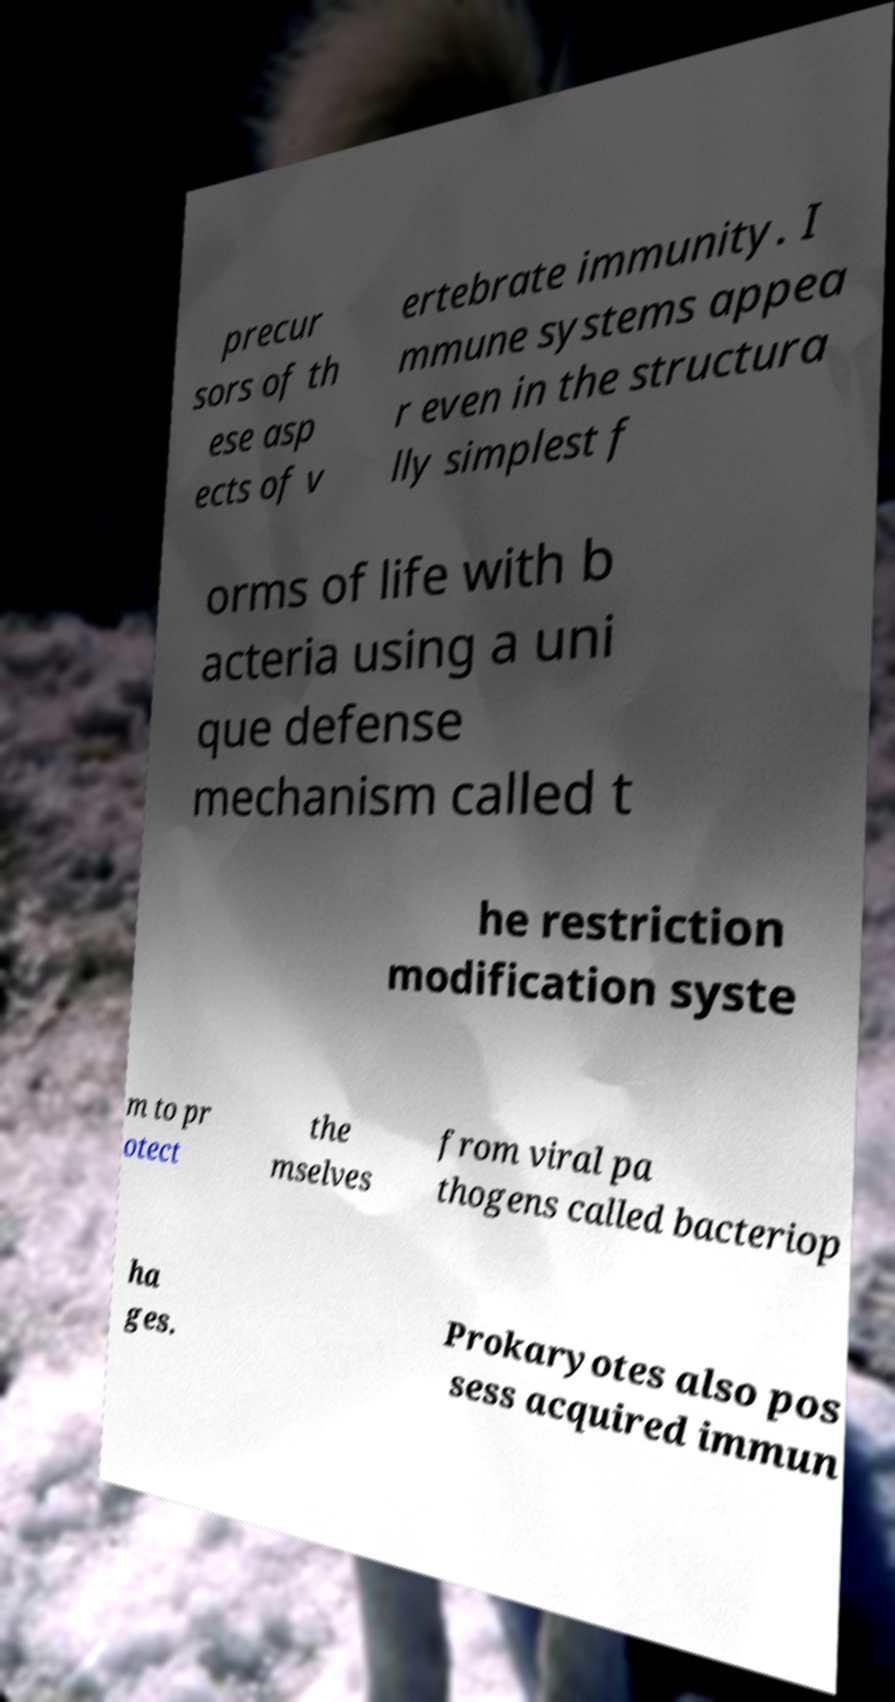What messages or text are displayed in this image? I need them in a readable, typed format. precur sors of th ese asp ects of v ertebrate immunity. I mmune systems appea r even in the structura lly simplest f orms of life with b acteria using a uni que defense mechanism called t he restriction modification syste m to pr otect the mselves from viral pa thogens called bacteriop ha ges. Prokaryotes also pos sess acquired immun 